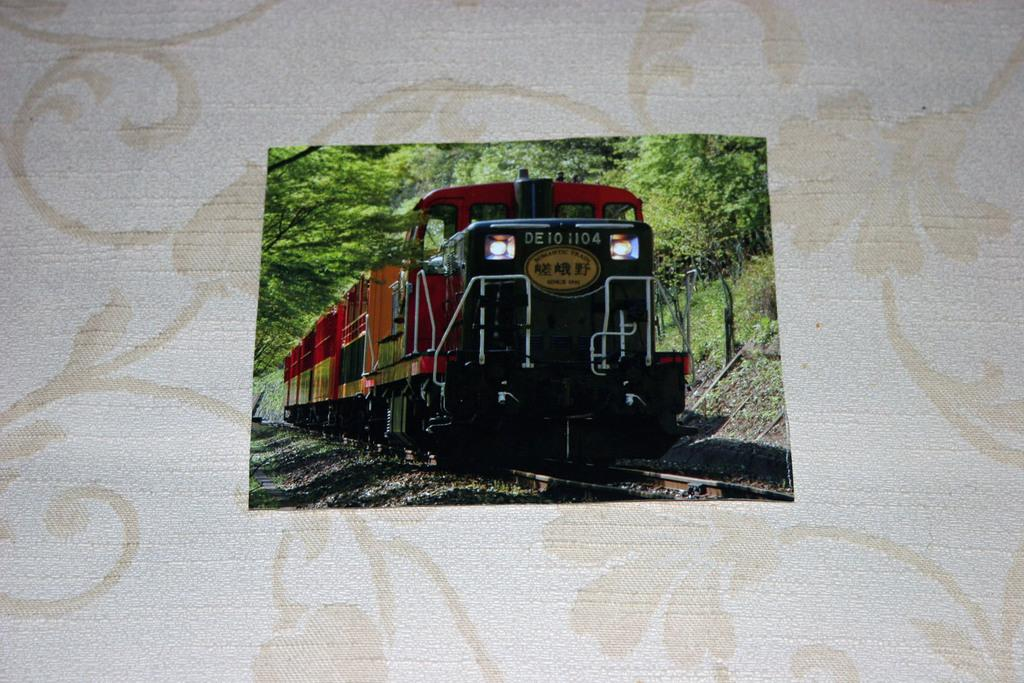What is the main subject of the image? The main subject of the image is a picture of a train. What can be seen in the background of the image? There are trees visible in the image. How does the goat react to the earthquake in the image? There is no goat or earthquake present in the image; it only features a picture of a train and trees in the background. 